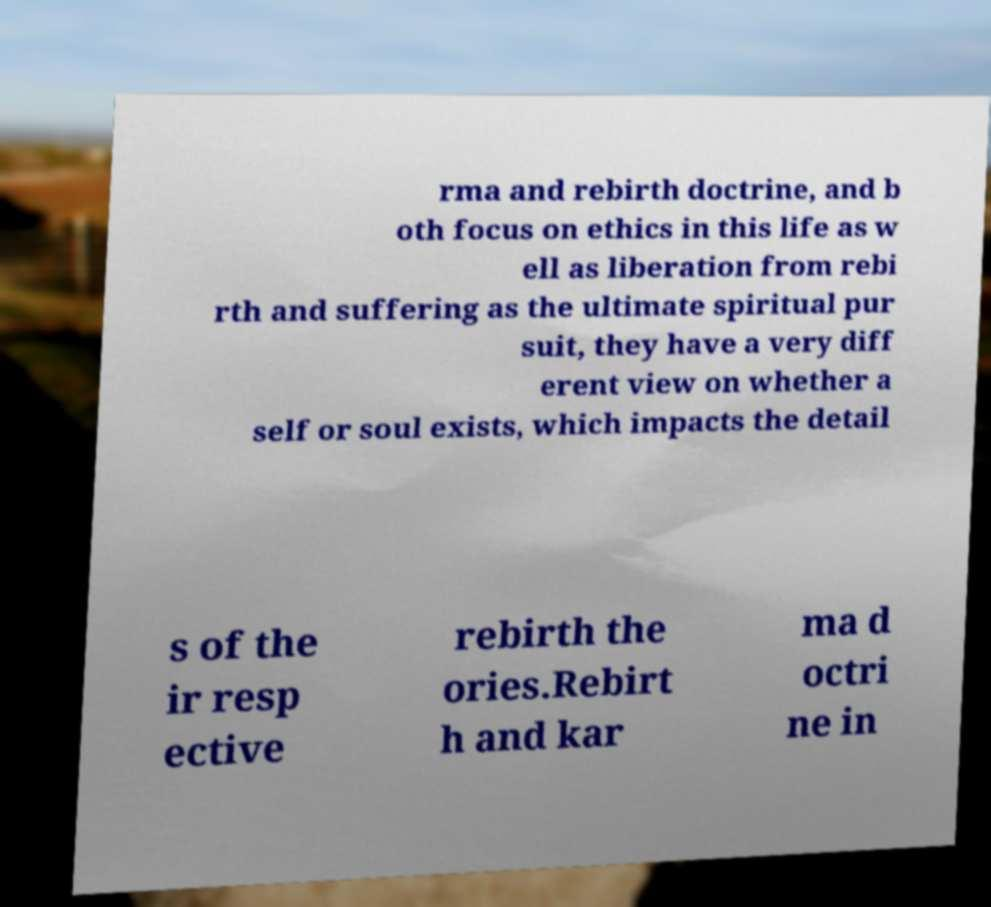For documentation purposes, I need the text within this image transcribed. Could you provide that? rma and rebirth doctrine, and b oth focus on ethics in this life as w ell as liberation from rebi rth and suffering as the ultimate spiritual pur suit, they have a very diff erent view on whether a self or soul exists, which impacts the detail s of the ir resp ective rebirth the ories.Rebirt h and kar ma d octri ne in 